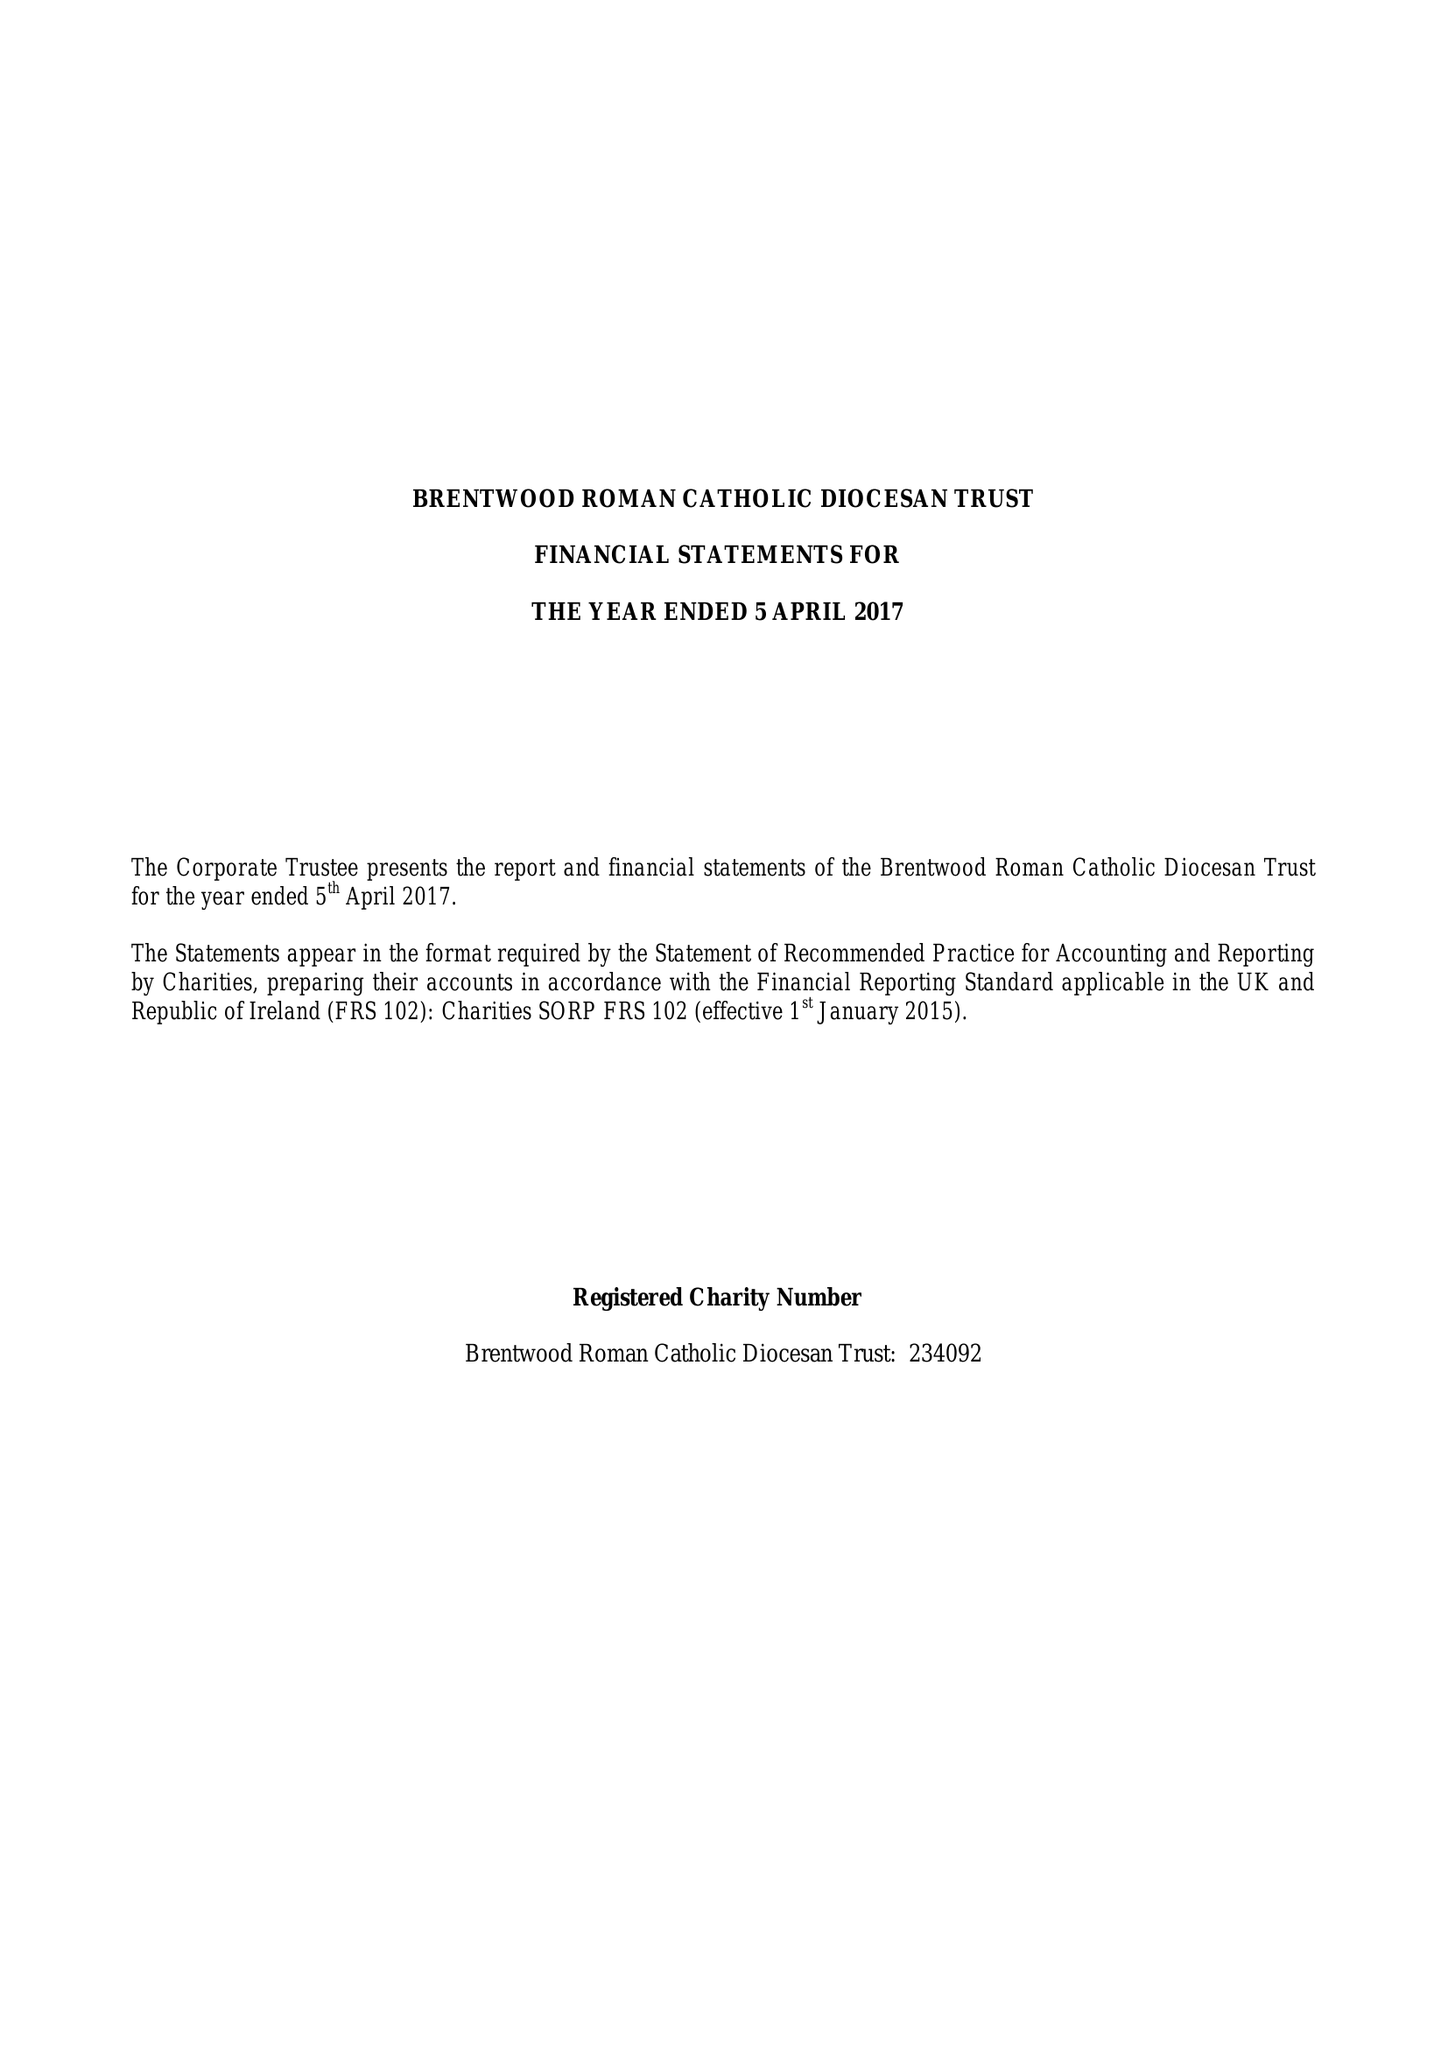What is the value for the income_annually_in_british_pounds?
Answer the question using a single word or phrase. 12586599.00 